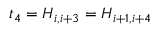Convert formula to latex. <formula><loc_0><loc_0><loc_500><loc_500>t _ { 4 } = H _ { i , i + 3 } = H _ { i + 1 , i + 4 }</formula> 